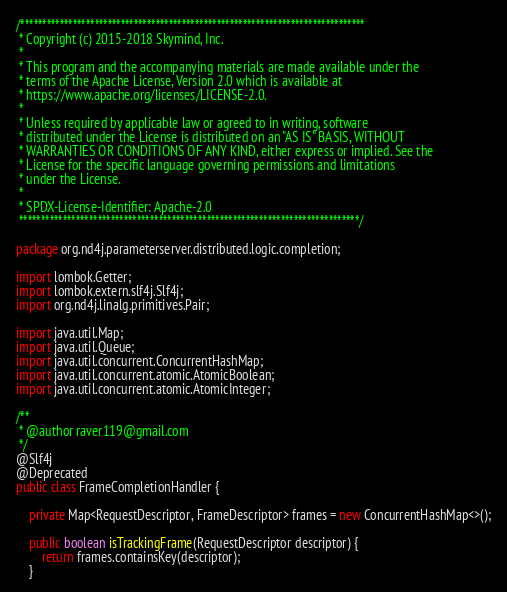<code> <loc_0><loc_0><loc_500><loc_500><_Java_>/*******************************************************************************
 * Copyright (c) 2015-2018 Skymind, Inc.
 *
 * This program and the accompanying materials are made available under the
 * terms of the Apache License, Version 2.0 which is available at
 * https://www.apache.org/licenses/LICENSE-2.0.
 *
 * Unless required by applicable law or agreed to in writing, software
 * distributed under the License is distributed on an "AS IS" BASIS, WITHOUT
 * WARRANTIES OR CONDITIONS OF ANY KIND, either express or implied. See the
 * License for the specific language governing permissions and limitations
 * under the License.
 *
 * SPDX-License-Identifier: Apache-2.0
 ******************************************************************************/

package org.nd4j.parameterserver.distributed.logic.completion;

import lombok.Getter;
import lombok.extern.slf4j.Slf4j;
import org.nd4j.linalg.primitives.Pair;

import java.util.Map;
import java.util.Queue;
import java.util.concurrent.ConcurrentHashMap;
import java.util.concurrent.atomic.AtomicBoolean;
import java.util.concurrent.atomic.AtomicInteger;

/**
 * @author raver119@gmail.com
 */
@Slf4j
@Deprecated
public class FrameCompletionHandler {

    private Map<RequestDescriptor, FrameDescriptor> frames = new ConcurrentHashMap<>();

    public boolean isTrackingFrame(RequestDescriptor descriptor) {
        return frames.containsKey(descriptor);
    }
</code> 